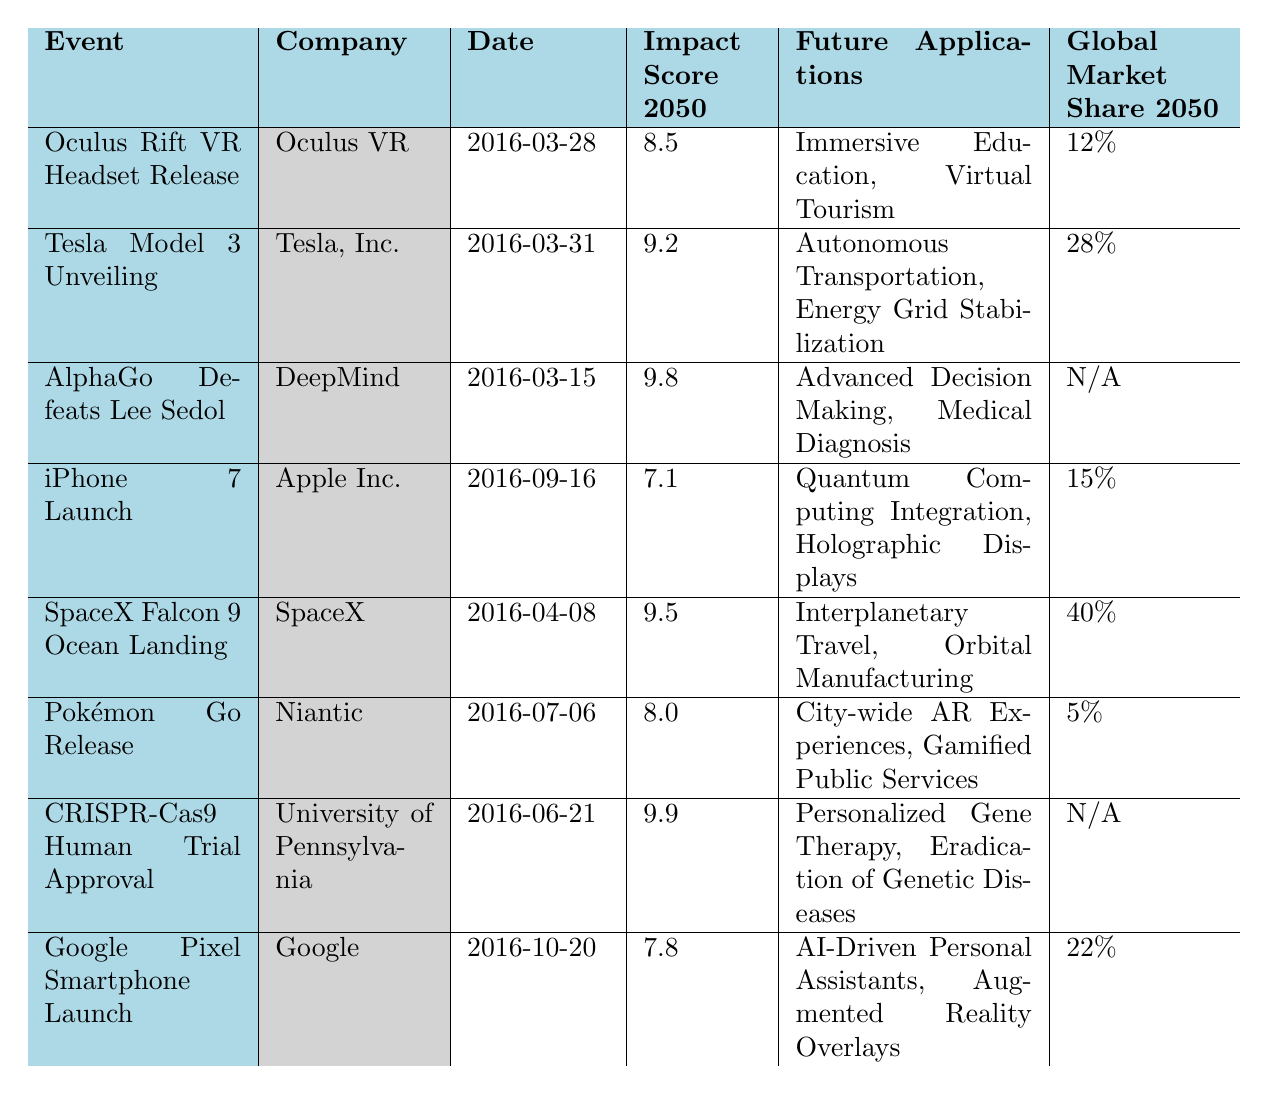What is the highest impact score among the events listed? By looking at the Impact Score column, it’s clear that the highest score is 9.9, which corresponds to the CRISPR-Cas9 Human Trial Approval event.
Answer: 9.9 Which company had the earliest event recorded? The earliest date listed in the table is for AlphaGo Defeats Lee Sedol on March 15, 2016, which is from DeepMind.
Answer: DeepMind How many events have a global market share of 15% or more? From the Global Market Share column, the events with a share of 15% or more are the Tesla Model 3 Unveiling (28%), SpaceX Falcon 9 Ocean Landing (40%), and Google Pixel Smartphone Launch (22%). That totals to three events.
Answer: 3 Is the impact score for the iPhone 7 higher than that of Pokémon Go? The Impact Score for iPhone 7 is 7.1, while for Pokémon Go it is 8.0. Since 7.1 is less than 8.0, the iPhone 7 does not have a higher impact score.
Answer: No What percentage of the total impact scores does the Tesla Model 3 Unveiling represent? First, calculate the total impact scores which are: (8.5 + 9.2 + 9.8 + 7.1 + 9.5 + 8.0 + 9.9 + 7.8) = 70.8. Then, divide the Tesla Model 3 Unveiling’s 9.2 by the total (9.2 / 70.8) and multiply by 100 to get the percentage. This gives approximately 12.99%.
Answer: Approximately 12.99% What are the future applications of the AlphaGo event? The Future Applications column for the AlphaGo Defeats Lee Sedol states "Advanced Decision Making, Medical Diagnosis." These applications highlight the significance of AI capabilities influenced by that event.
Answer: Advanced Decision Making, Medical Diagnosis Which event had the lowest global market share and what was its score? Looking at the Global Market Share column, Pokémon Go had the lowest share at 5%. The corresponding impact score for Pokémon Go is 8.0.
Answer: 5%, 8.0 How many events were launched in the month of March? From the table, there are three events that listed their date in March: Oculus Rift VR Headset Release (March 28), Tesla Model 3 Unveiling (March 31), and AlphaGo Defeats Lee Sedol (March 15). Counting these gives a total of three events launched in March.
Answer: 3 Are all the events listed in 2016? Each event in the table has a date in 2016. Since there are no entries from any other year, we can confirm all events are in 2016.
Answer: Yes What is the difference in global market share between the SpaceX event and the iPhone 7 event? The Global Market Share for SpaceX Falcon 9 Ocean Landing is 40% while for iPhone 7 it is 15%. The difference is calculated as 40% - 15% = 25%.
Answer: 25% What implications does the CRISPR-Cas9 event have for future medical advancements? The Future Applications column for CRISPR-Cas9 Human Trial Approval states "Personalized Gene Therapy, Eradication of Genetic Diseases," implying significant advancements and potential for individual-specific treatments in medicine.
Answer: Personalized Gene Therapy, Eradication of Genetic Diseases 